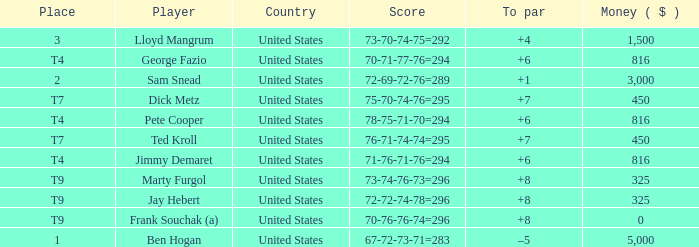Which country is Pete Cooper, who made $816, from? United States. 